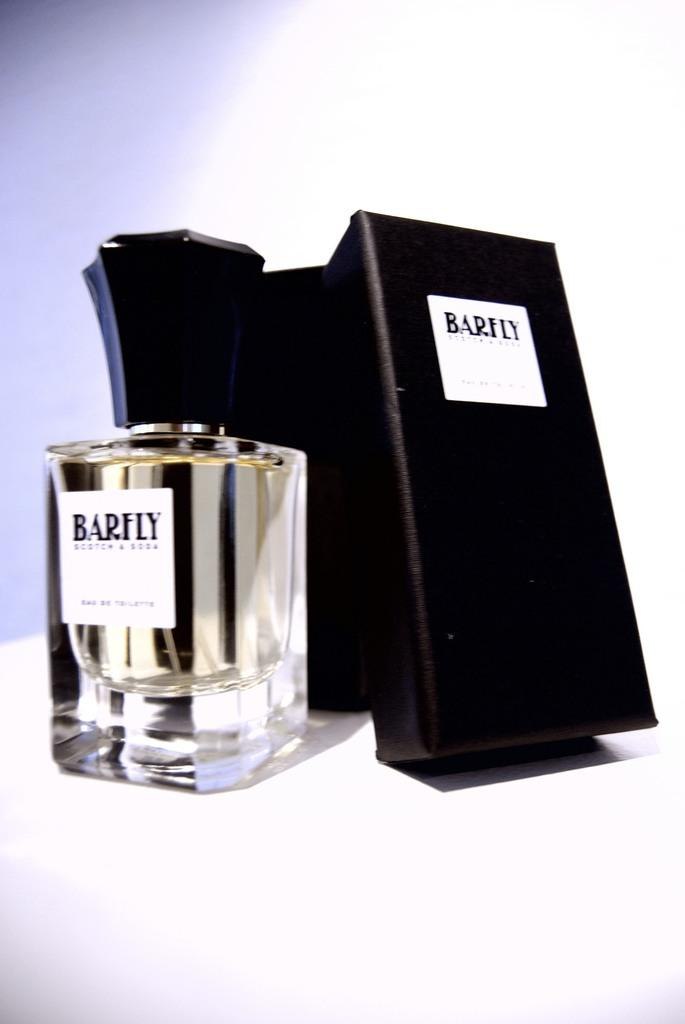<image>
Summarize the visual content of the image. A bottle of Barley branded perfume with its black box sitting next to it. 